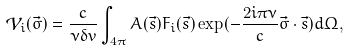Convert formula to latex. <formula><loc_0><loc_0><loc_500><loc_500>\mathcal { V } _ { i } ( \vec { \sigma } ) = \frac { c } { \nu \delta v } \int _ { 4 \pi } A ( \vec { s } ) F _ { i } ( \vec { s } ) \exp ( - \frac { 2 i \pi \nu } { c } \vec { \sigma } \cdot \vec { s } ) d \Omega ,</formula> 